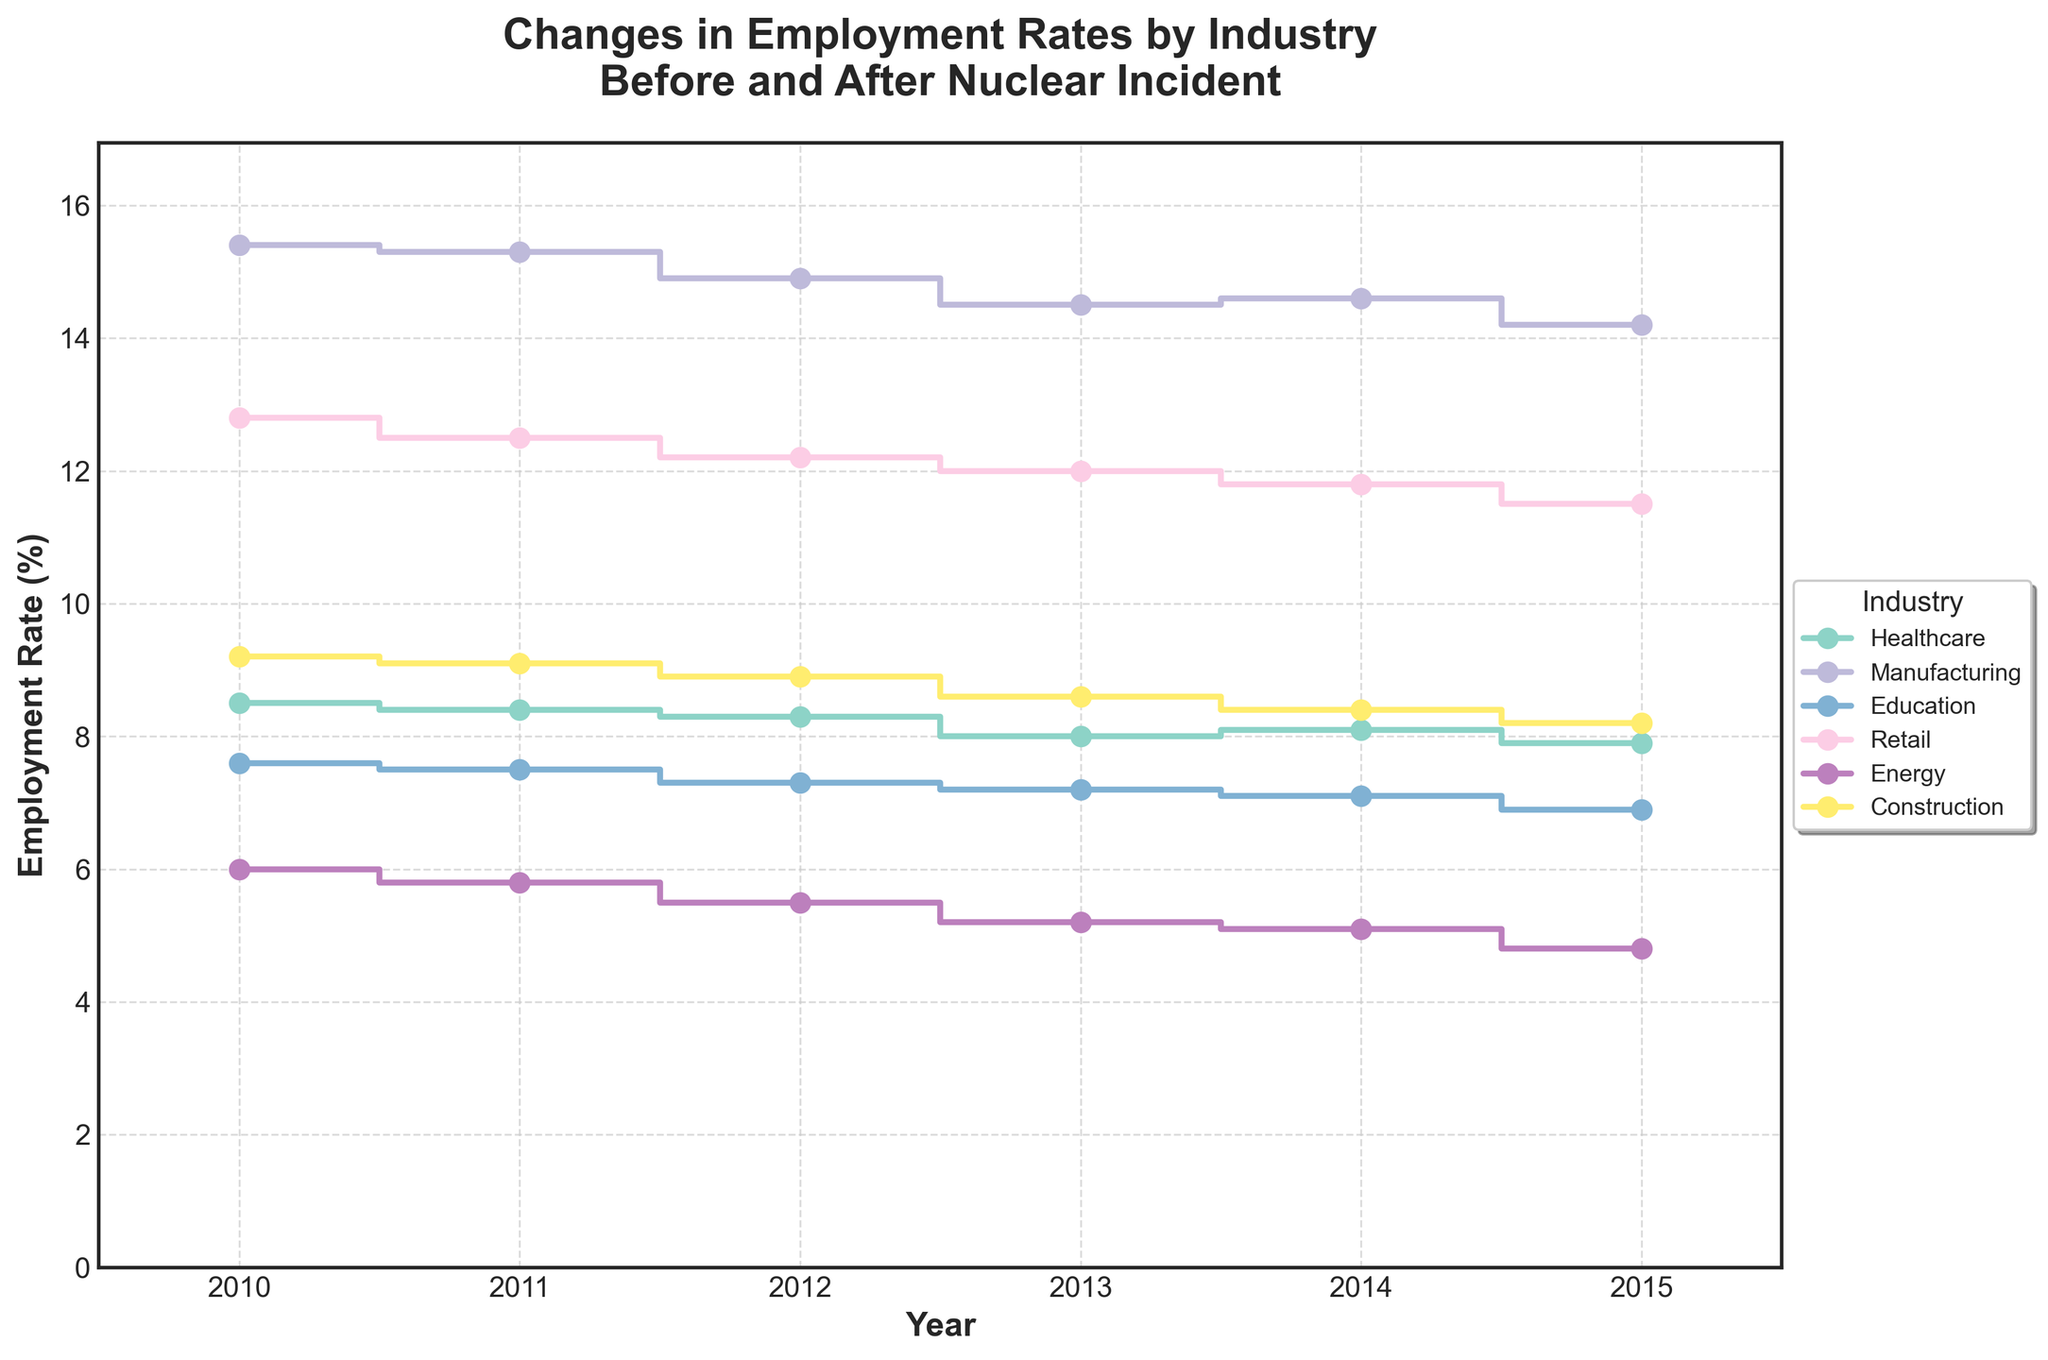What's the title of the figure? The title is located at the top of the figure and reads: "Changes in Employment Rates by Industry Before and After Nuclear Incident".
Answer: Changes in Employment Rates by Industry Before and After Nuclear Incident What are the units used on the y-axis? Looking at the y-axis label, it reads: "Employment Rate (%)", indicating that the unit is percentage.
Answer: Percentage Which industry had the highest employment rate in 2010? By examining the step lines for each industry, the industry with the highest employment rate in 2010 has the largest y-value at that year. Manufacturing is at the top with a value around 15.4%.
Answer: Manufacturing How did the employment rate for the Energy industry change from 2010 to 2015? Trace the step for the Energy industry from 2010 to 2015. It started at 6.0% in 2010 and decreased to 4.8% by 2015.
Answer: Decreased from 6.0% to 4.8% Which two industries had the smallest employment rate decrease from 2011 to 2013? By comparing the change for each industry between 2011 and 2013, the smallest decreases are observed for Healthcare (from 8.4% to 8.0%) and Construction (from 9.1% to 8.6%).
Answer: Healthcare and Construction What trend is observed in the Manufacturing industry's employment rate from 2010 to 2015? Following the step plot for Manufacturing, there is an overall decreasing trend from 15.4% in 2010 to approximately 14.2% in 2015.
Answer: Decreasing trend How much did the employment rate in Retail change between 2010 and 2015? The employment rate in Retail started at 12.8% in 2010 and decreased to 11.5% in 2015. The change is 12.8% - 11.5% = 1.3%.
Answer: 1.3% What is the average employment rate for the Education industry from 2010 to 2015? Sum the employment rates for Education for each year from 2010 to 2015 and divide by the number of years. (7.6 + 7.5 + 7.3 + 7.2 + 7.1 + 6.9) / 6 = 7.27%
Answer: 7.27% Which industry displayed the most stability in employment rates from 2010 to 2015? Comparing the variation across the years, Healthcare appears most stable, with 8.5% in 2010 and ending at 7.9% in 2015, showing least variation compared to others.
Answer: Healthcare What is the largest difference in employment rate for any industry between two consecutive years? Examining the changes between each year for all industries, the largest difference occurs in Manufacturing between 2012 and 2013, dropping from 14.9% to 14.5%, a difference of 0.4%.
Answer: 0.4% 